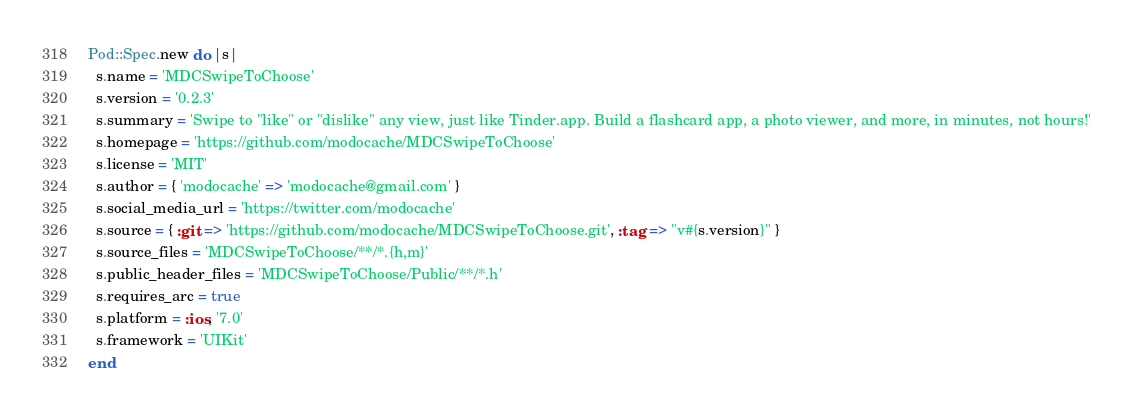<code> <loc_0><loc_0><loc_500><loc_500><_Ruby_>Pod::Spec.new do |s|
  s.name = 'MDCSwipeToChoose'
  s.version = '0.2.3'
  s.summary = 'Swipe to "like" or "dislike" any view, just like Tinder.app. Build a flashcard app, a photo viewer, and more, in minutes, not hours!'
  s.homepage = 'https://github.com/modocache/MDCSwipeToChoose'
  s.license = 'MIT'
  s.author = { 'modocache' => 'modocache@gmail.com' }
  s.social_media_url = 'https://twitter.com/modocache'
  s.source = { :git => 'https://github.com/modocache/MDCSwipeToChoose.git', :tag => "v#{s.version}" }
  s.source_files = 'MDCSwipeToChoose/**/*.{h,m}'
  s.public_header_files = 'MDCSwipeToChoose/Public/**/*.h'
  s.requires_arc = true
  s.platform = :ios, '7.0'
  s.framework = 'UIKit'
end

</code> 